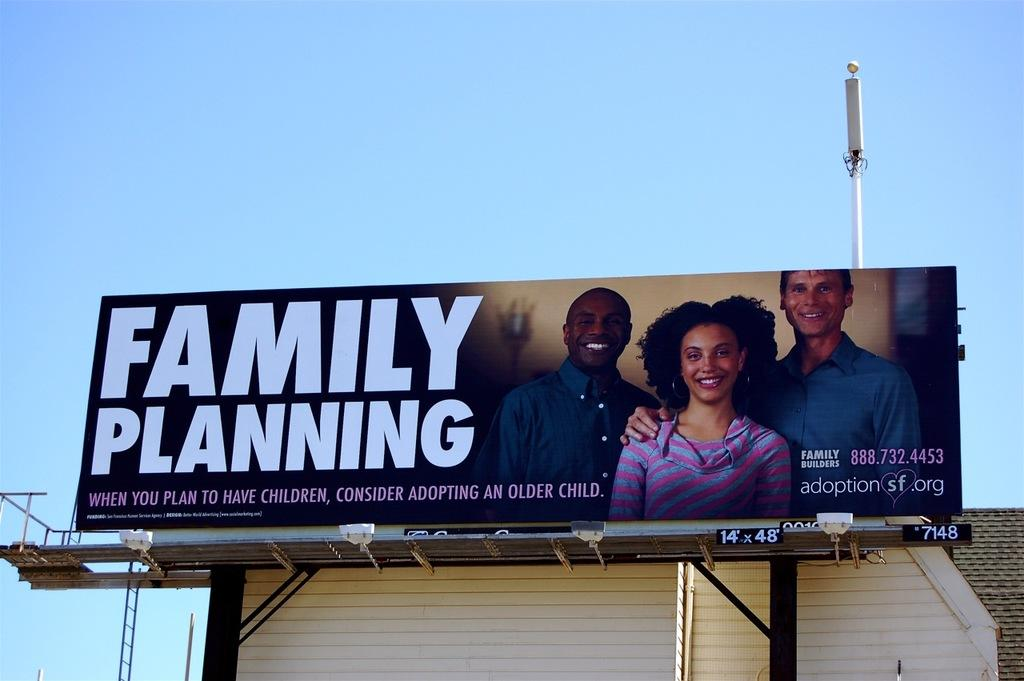<image>
Relay a brief, clear account of the picture shown. A billboard for Family Planning with three people 